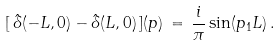<formula> <loc_0><loc_0><loc_500><loc_500>[ \, \hat { \delta } ( - L , 0 ) - \hat { \delta } ( L , 0 ) \, ] ( p ) \, = \, \frac { i } { \pi } \sin ( p _ { 1 } L ) \, .</formula> 